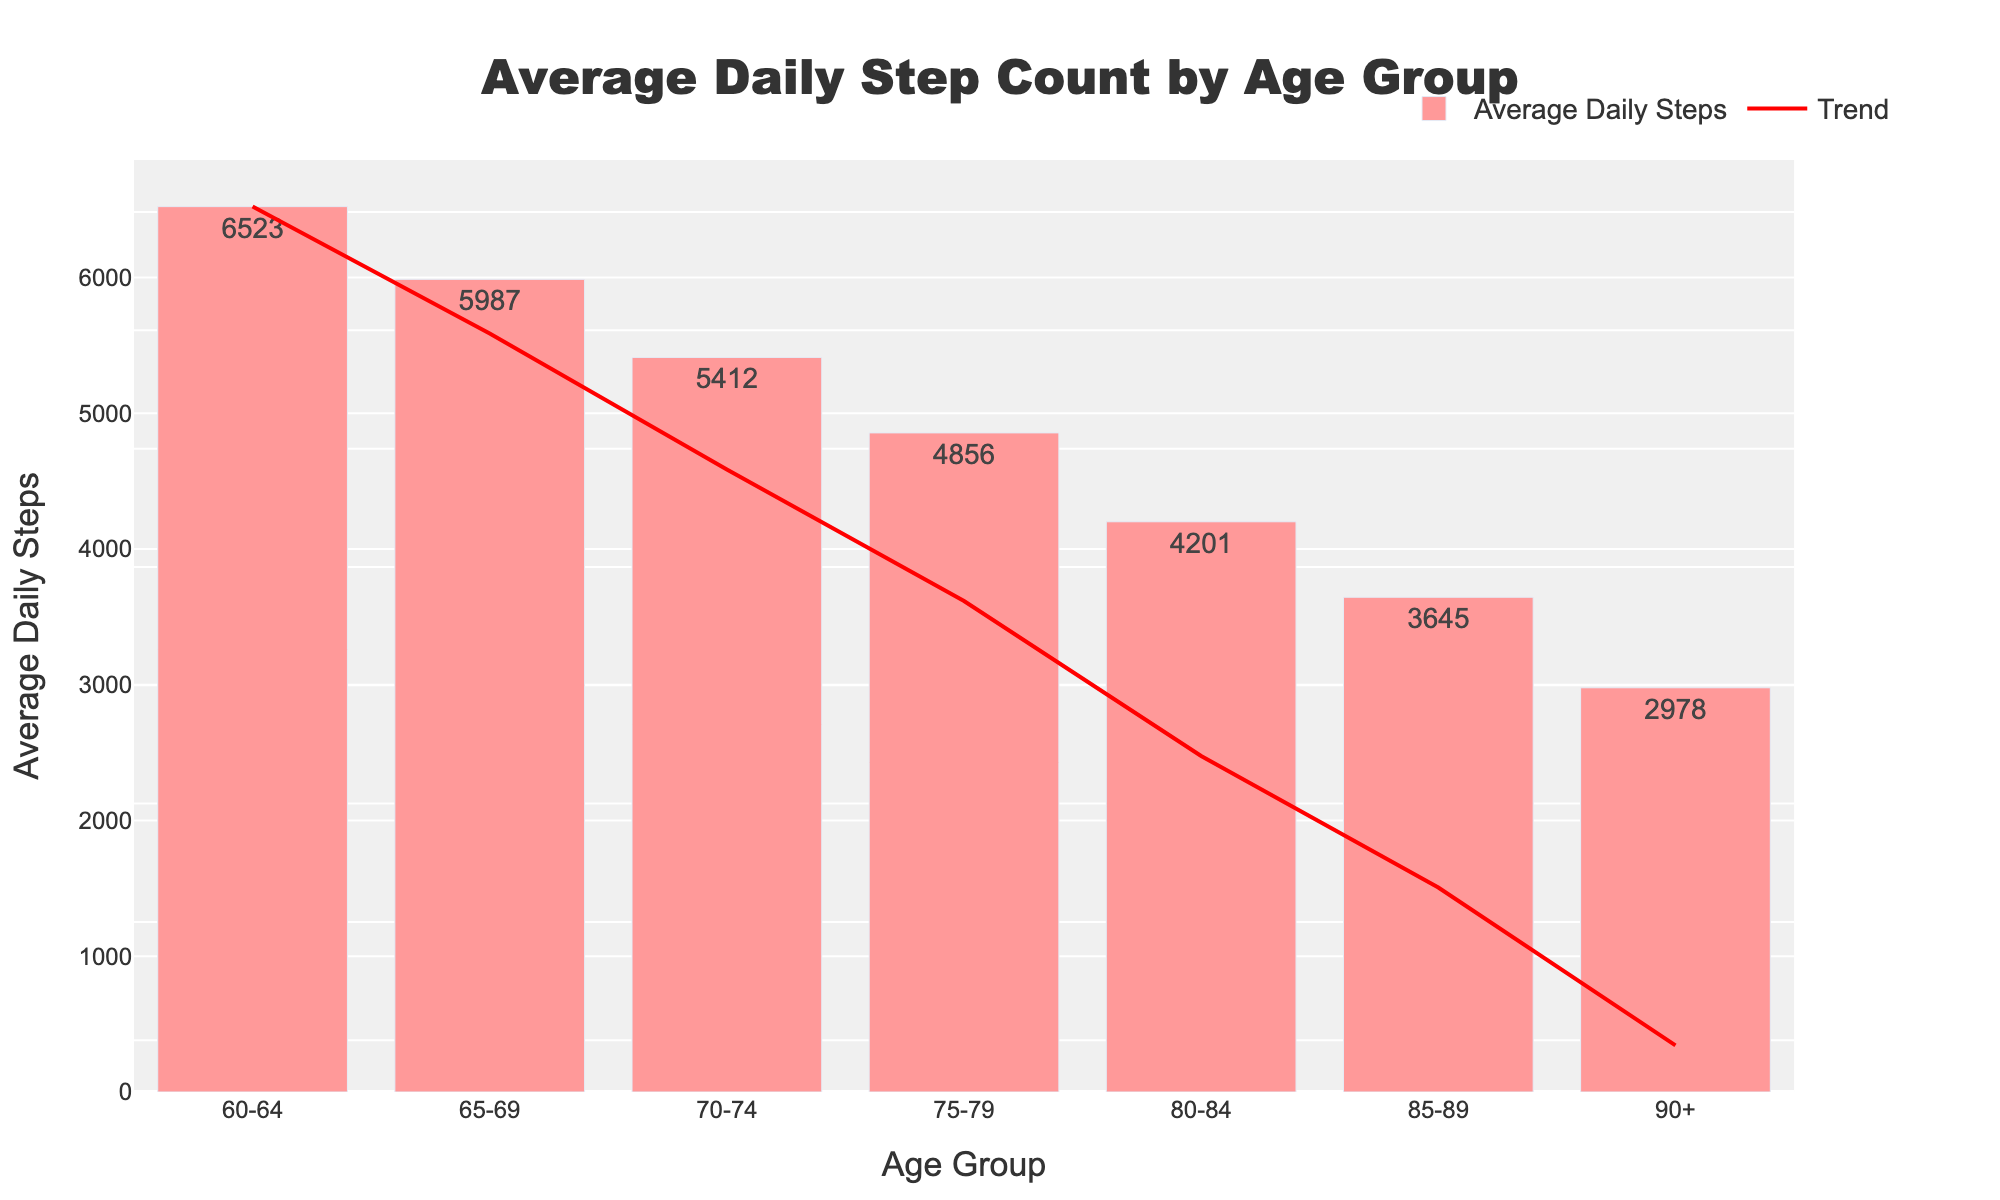Which age group has the highest average daily step count? The bar chart shows the highest bar for the "60-64" age group, indicating it has the highest average daily step count.
Answer: 60-64 Which age group has the lowest average daily step count? The shortest bar in the bar chart corresponds to the "90+" age group, indicating it has the lowest average daily step count.
Answer: 90+ How many more steps does the 70-74 age group take compared to the 80-84 age group? The average daily step count for the 70-74 age group is 5412 and for the 80-84 age group is 4201. The difference is 5412 - 4201 = 1211 steps.
Answer: 1211 Which age group has a higher daily step count: 65-69 or 75-79? The bar for the 65-69 age group is higher than the bar for the 75-79 age group, indicating that the 65-69 age group has a higher daily step count.
Answer: 65-69 What is the trend shown by the line in the bar chart? The line in the chart starts high at the 60-64 age group and gradually decreases with each subsequent age group, indicating a downward trend in average daily step counts as age increases.
Answer: Decreasing By how much does the average daily step count decrease from the 60-64 age group to the 65-69 age group? The average daily step count for the 60-64 age group is 6523 and for the 65-69 age group is 5987. The difference is 6523 - 5987 = 536 steps.
Answer: 536 What are the average daily step counts for the 75-79 and 80-84 age groups combined? The average daily step count for the 75-79 age group is 4856 and for the 80-84 age group is 4201. Combining them gives 4856 + 4201 = 9057 steps.
Answer: 9057 Is the average daily step count of the 70-74 age group closer to that of the 65-69 age group or the 75-79 age group? The average daily step count for the 70-74 age group is 5412. The count for the 65-69 age group is 5987, and for the 75-79 age group is 4856. The differences are 5987 - 5412 = 575 and 5412 - 4856 = 556. Since 556 is less than 575, it is closer to the 75-79 age group.
Answer: 75-79 How many steps does the 85-89 age group take on average compared to the youngest and oldest age groups combined? The average daily step count for the 85-89 age group is 3645. The combined step counts for the 60-64 and 90+ groups are 6523 + 2978 = 9501. The difference is 9501 - 3645 = 5856 steps.
Answer: 5856 steps less 